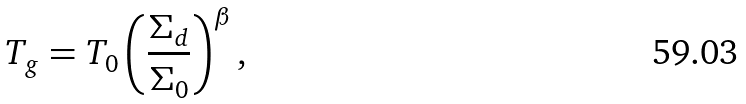<formula> <loc_0><loc_0><loc_500><loc_500>T _ { g } = T _ { 0 } \left ( \frac { \Sigma _ { d } } { \Sigma _ { 0 } } \right ) ^ { \beta } ,</formula> 